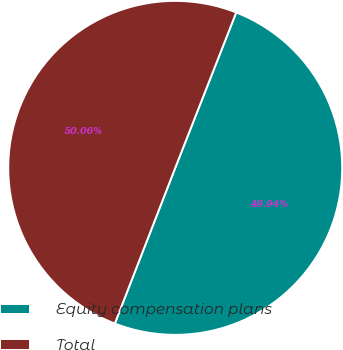Convert chart. <chart><loc_0><loc_0><loc_500><loc_500><pie_chart><fcel>Equity compensation plans<fcel>Total<nl><fcel>49.94%<fcel>50.06%<nl></chart> 